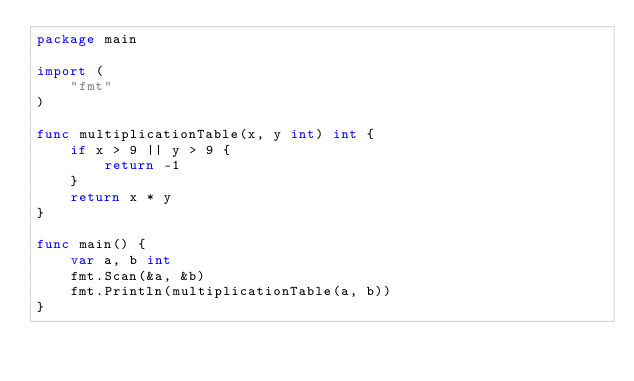<code> <loc_0><loc_0><loc_500><loc_500><_Go_>package main

import (
	"fmt"
)

func multiplicationTable(x, y int) int {
	if x > 9 || y > 9 {
		return -1
	}
	return x * y
}

func main() {
	var a, b int
	fmt.Scan(&a, &b)
	fmt.Println(multiplicationTable(a, b))
}
</code> 